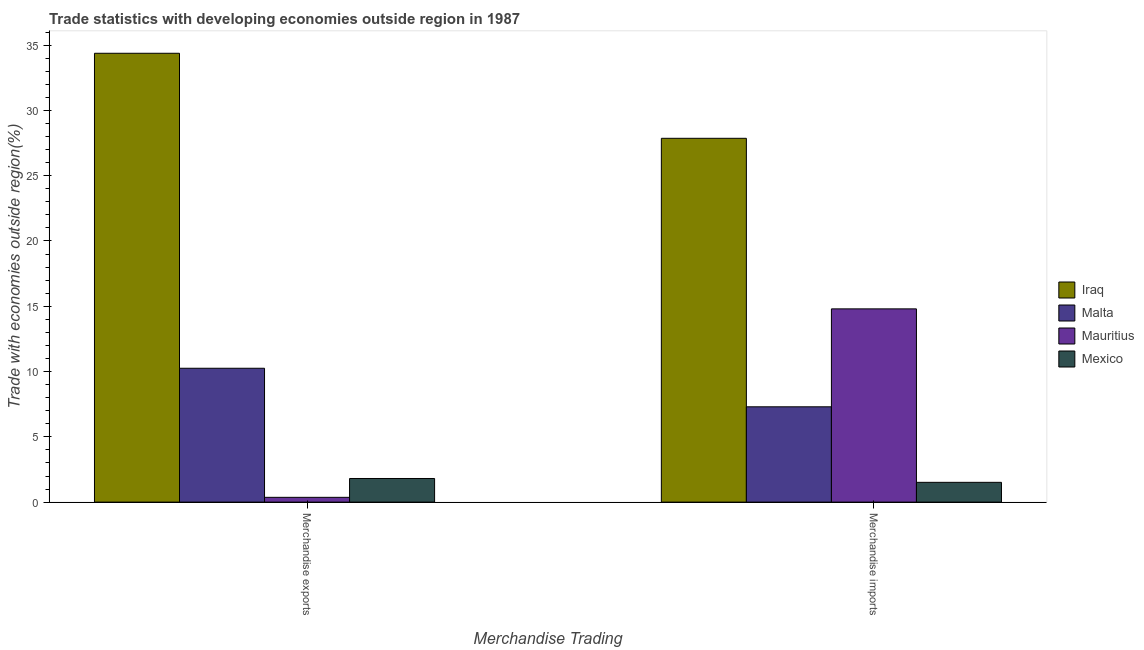How many different coloured bars are there?
Provide a succinct answer. 4. How many groups of bars are there?
Ensure brevity in your answer.  2. Are the number of bars per tick equal to the number of legend labels?
Keep it short and to the point. Yes. How many bars are there on the 1st tick from the left?
Ensure brevity in your answer.  4. How many bars are there on the 1st tick from the right?
Keep it short and to the point. 4. What is the label of the 2nd group of bars from the left?
Give a very brief answer. Merchandise imports. What is the merchandise exports in Mexico?
Your answer should be very brief. 1.81. Across all countries, what is the maximum merchandise imports?
Provide a succinct answer. 27.86. Across all countries, what is the minimum merchandise exports?
Your answer should be compact. 0.37. In which country was the merchandise exports maximum?
Keep it short and to the point. Iraq. In which country was the merchandise exports minimum?
Your answer should be very brief. Mauritius. What is the total merchandise imports in the graph?
Keep it short and to the point. 51.48. What is the difference between the merchandise imports in Iraq and that in Mexico?
Make the answer very short. 26.35. What is the difference between the merchandise imports in Mauritius and the merchandise exports in Malta?
Give a very brief answer. 4.55. What is the average merchandise exports per country?
Make the answer very short. 11.7. What is the difference between the merchandise imports and merchandise exports in Iraq?
Give a very brief answer. -6.51. In how many countries, is the merchandise imports greater than 11 %?
Offer a very short reply. 2. What is the ratio of the merchandise imports in Malta to that in Mauritius?
Your answer should be very brief. 0.49. Is the merchandise exports in Malta less than that in Iraq?
Your answer should be very brief. Yes. What does the 3rd bar from the left in Merchandise exports represents?
Provide a succinct answer. Mauritius. What does the 1st bar from the right in Merchandise exports represents?
Keep it short and to the point. Mexico. Are all the bars in the graph horizontal?
Your response must be concise. No. How many countries are there in the graph?
Your answer should be very brief. 4. Are the values on the major ticks of Y-axis written in scientific E-notation?
Offer a terse response. No. Does the graph contain any zero values?
Give a very brief answer. No. Where does the legend appear in the graph?
Offer a terse response. Center right. What is the title of the graph?
Offer a very short reply. Trade statistics with developing economies outside region in 1987. Does "Congo (Republic)" appear as one of the legend labels in the graph?
Ensure brevity in your answer.  No. What is the label or title of the X-axis?
Keep it short and to the point. Merchandise Trading. What is the label or title of the Y-axis?
Your answer should be compact. Trade with economies outside region(%). What is the Trade with economies outside region(%) in Iraq in Merchandise exports?
Your answer should be compact. 34.38. What is the Trade with economies outside region(%) in Malta in Merchandise exports?
Ensure brevity in your answer.  10.25. What is the Trade with economies outside region(%) of Mauritius in Merchandise exports?
Provide a succinct answer. 0.37. What is the Trade with economies outside region(%) of Mexico in Merchandise exports?
Your response must be concise. 1.81. What is the Trade with economies outside region(%) of Iraq in Merchandise imports?
Your answer should be compact. 27.86. What is the Trade with economies outside region(%) of Malta in Merchandise imports?
Offer a terse response. 7.3. What is the Trade with economies outside region(%) of Mauritius in Merchandise imports?
Keep it short and to the point. 14.8. What is the Trade with economies outside region(%) in Mexico in Merchandise imports?
Your answer should be very brief. 1.52. Across all Merchandise Trading, what is the maximum Trade with economies outside region(%) of Iraq?
Offer a very short reply. 34.38. Across all Merchandise Trading, what is the maximum Trade with economies outside region(%) of Malta?
Your answer should be very brief. 10.25. Across all Merchandise Trading, what is the maximum Trade with economies outside region(%) in Mauritius?
Give a very brief answer. 14.8. Across all Merchandise Trading, what is the maximum Trade with economies outside region(%) of Mexico?
Your answer should be compact. 1.81. Across all Merchandise Trading, what is the minimum Trade with economies outside region(%) of Iraq?
Ensure brevity in your answer.  27.86. Across all Merchandise Trading, what is the minimum Trade with economies outside region(%) in Malta?
Ensure brevity in your answer.  7.3. Across all Merchandise Trading, what is the minimum Trade with economies outside region(%) of Mauritius?
Make the answer very short. 0.37. Across all Merchandise Trading, what is the minimum Trade with economies outside region(%) in Mexico?
Keep it short and to the point. 1.52. What is the total Trade with economies outside region(%) of Iraq in the graph?
Ensure brevity in your answer.  62.24. What is the total Trade with economies outside region(%) in Malta in the graph?
Give a very brief answer. 17.55. What is the total Trade with economies outside region(%) of Mauritius in the graph?
Your answer should be very brief. 15.17. What is the total Trade with economies outside region(%) in Mexico in the graph?
Your answer should be very brief. 3.33. What is the difference between the Trade with economies outside region(%) in Iraq in Merchandise exports and that in Merchandise imports?
Keep it short and to the point. 6.51. What is the difference between the Trade with economies outside region(%) of Malta in Merchandise exports and that in Merchandise imports?
Offer a terse response. 2.95. What is the difference between the Trade with economies outside region(%) in Mauritius in Merchandise exports and that in Merchandise imports?
Offer a terse response. -14.43. What is the difference between the Trade with economies outside region(%) of Mexico in Merchandise exports and that in Merchandise imports?
Offer a very short reply. 0.29. What is the difference between the Trade with economies outside region(%) of Iraq in Merchandise exports and the Trade with economies outside region(%) of Malta in Merchandise imports?
Offer a very short reply. 27.08. What is the difference between the Trade with economies outside region(%) of Iraq in Merchandise exports and the Trade with economies outside region(%) of Mauritius in Merchandise imports?
Your answer should be compact. 19.58. What is the difference between the Trade with economies outside region(%) of Iraq in Merchandise exports and the Trade with economies outside region(%) of Mexico in Merchandise imports?
Ensure brevity in your answer.  32.86. What is the difference between the Trade with economies outside region(%) in Malta in Merchandise exports and the Trade with economies outside region(%) in Mauritius in Merchandise imports?
Give a very brief answer. -4.55. What is the difference between the Trade with economies outside region(%) in Malta in Merchandise exports and the Trade with economies outside region(%) in Mexico in Merchandise imports?
Keep it short and to the point. 8.74. What is the difference between the Trade with economies outside region(%) in Mauritius in Merchandise exports and the Trade with economies outside region(%) in Mexico in Merchandise imports?
Your answer should be compact. -1.15. What is the average Trade with economies outside region(%) in Iraq per Merchandise Trading?
Provide a short and direct response. 31.12. What is the average Trade with economies outside region(%) of Malta per Merchandise Trading?
Your answer should be very brief. 8.78. What is the average Trade with economies outside region(%) of Mauritius per Merchandise Trading?
Make the answer very short. 7.58. What is the average Trade with economies outside region(%) of Mexico per Merchandise Trading?
Provide a succinct answer. 1.66. What is the difference between the Trade with economies outside region(%) of Iraq and Trade with economies outside region(%) of Malta in Merchandise exports?
Make the answer very short. 24.12. What is the difference between the Trade with economies outside region(%) of Iraq and Trade with economies outside region(%) of Mauritius in Merchandise exports?
Provide a succinct answer. 34.01. What is the difference between the Trade with economies outside region(%) of Iraq and Trade with economies outside region(%) of Mexico in Merchandise exports?
Offer a terse response. 32.56. What is the difference between the Trade with economies outside region(%) of Malta and Trade with economies outside region(%) of Mauritius in Merchandise exports?
Provide a short and direct response. 9.89. What is the difference between the Trade with economies outside region(%) in Malta and Trade with economies outside region(%) in Mexico in Merchandise exports?
Ensure brevity in your answer.  8.44. What is the difference between the Trade with economies outside region(%) of Mauritius and Trade with economies outside region(%) of Mexico in Merchandise exports?
Your response must be concise. -1.44. What is the difference between the Trade with economies outside region(%) of Iraq and Trade with economies outside region(%) of Malta in Merchandise imports?
Ensure brevity in your answer.  20.56. What is the difference between the Trade with economies outside region(%) of Iraq and Trade with economies outside region(%) of Mauritius in Merchandise imports?
Ensure brevity in your answer.  13.06. What is the difference between the Trade with economies outside region(%) in Iraq and Trade with economies outside region(%) in Mexico in Merchandise imports?
Provide a succinct answer. 26.35. What is the difference between the Trade with economies outside region(%) of Malta and Trade with economies outside region(%) of Mauritius in Merchandise imports?
Keep it short and to the point. -7.5. What is the difference between the Trade with economies outside region(%) in Malta and Trade with economies outside region(%) in Mexico in Merchandise imports?
Ensure brevity in your answer.  5.78. What is the difference between the Trade with economies outside region(%) in Mauritius and Trade with economies outside region(%) in Mexico in Merchandise imports?
Provide a succinct answer. 13.28. What is the ratio of the Trade with economies outside region(%) of Iraq in Merchandise exports to that in Merchandise imports?
Offer a terse response. 1.23. What is the ratio of the Trade with economies outside region(%) in Malta in Merchandise exports to that in Merchandise imports?
Give a very brief answer. 1.4. What is the ratio of the Trade with economies outside region(%) of Mauritius in Merchandise exports to that in Merchandise imports?
Make the answer very short. 0.02. What is the ratio of the Trade with economies outside region(%) of Mexico in Merchandise exports to that in Merchandise imports?
Provide a succinct answer. 1.19. What is the difference between the highest and the second highest Trade with economies outside region(%) of Iraq?
Provide a succinct answer. 6.51. What is the difference between the highest and the second highest Trade with economies outside region(%) of Malta?
Make the answer very short. 2.95. What is the difference between the highest and the second highest Trade with economies outside region(%) in Mauritius?
Your answer should be very brief. 14.43. What is the difference between the highest and the second highest Trade with economies outside region(%) of Mexico?
Offer a terse response. 0.29. What is the difference between the highest and the lowest Trade with economies outside region(%) in Iraq?
Give a very brief answer. 6.51. What is the difference between the highest and the lowest Trade with economies outside region(%) of Malta?
Provide a succinct answer. 2.95. What is the difference between the highest and the lowest Trade with economies outside region(%) of Mauritius?
Make the answer very short. 14.43. What is the difference between the highest and the lowest Trade with economies outside region(%) in Mexico?
Ensure brevity in your answer.  0.29. 